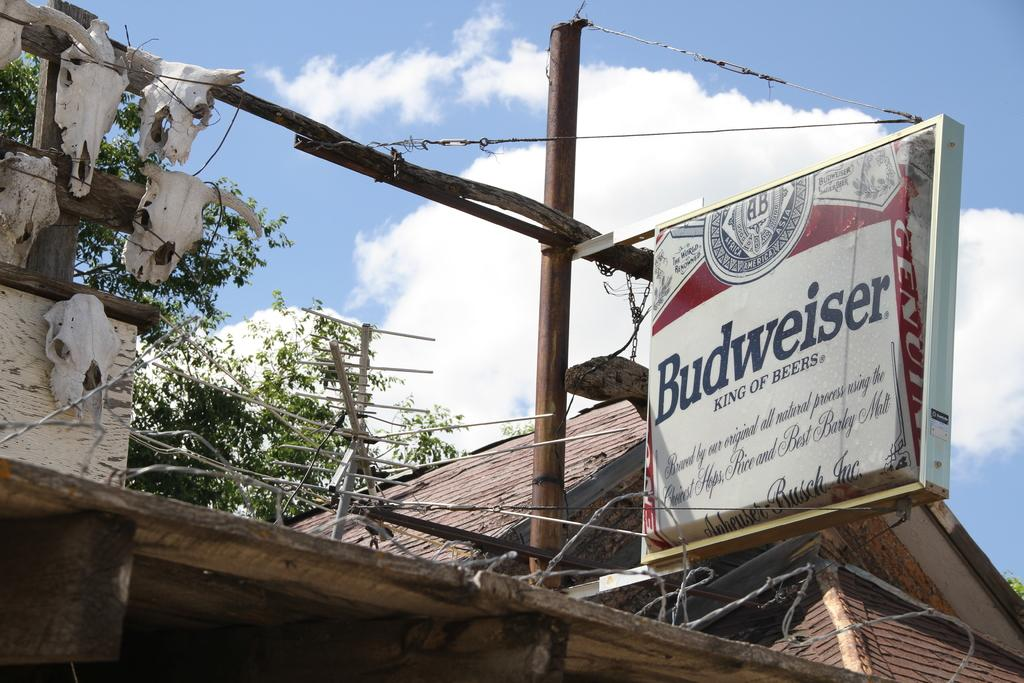What type of structure is present in the image? There is a building in the image. What object can be seen in front of the building? There is a board in the image. What can be seen in the distance behind the building? There are trees in the background of the image. What is visible above the trees and building in the image? The sky is visible in the background of the image. Where is the toothbrush stored in the image? There is no toothbrush present in the image. What type of jar is visible on the board in the image? There is no jar visible on the board in the image. 